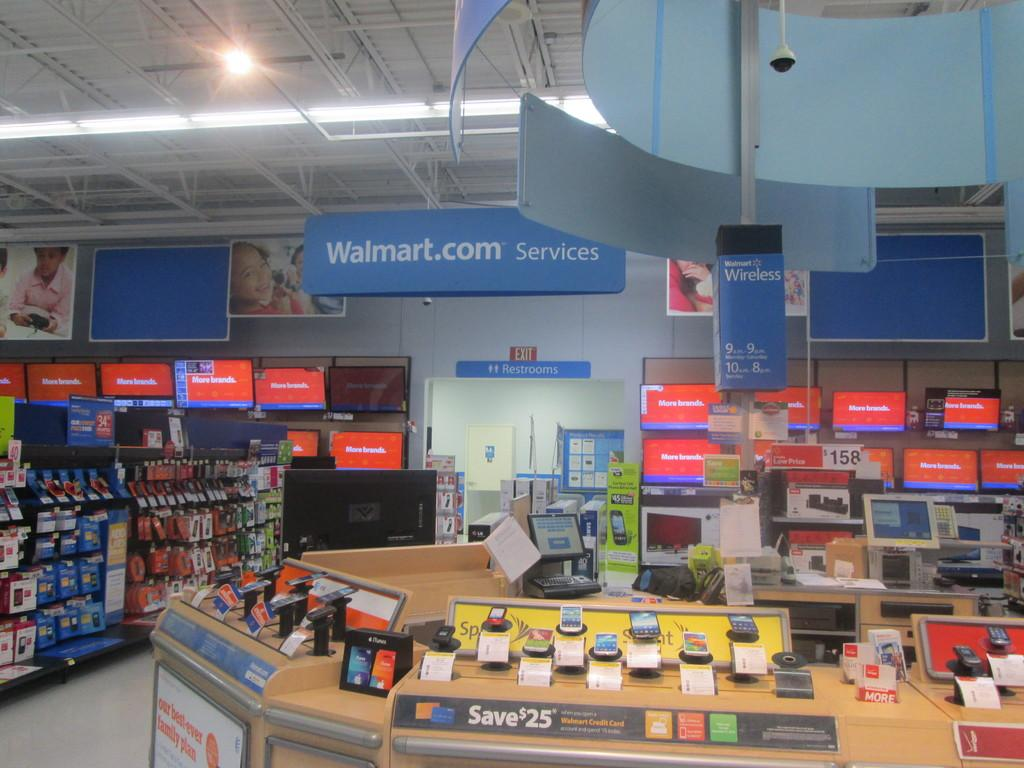<image>
Render a clear and concise summary of the photo. A Walmart.com services section of a department store 